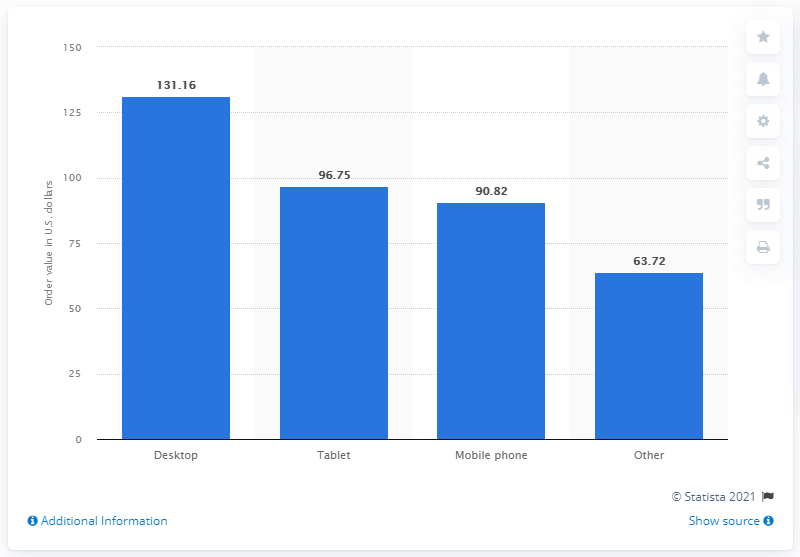Highlight a few significant elements in this photo. In the second quarter of 2020, the average value of online orders placed from a desktop computer was 131.16. 